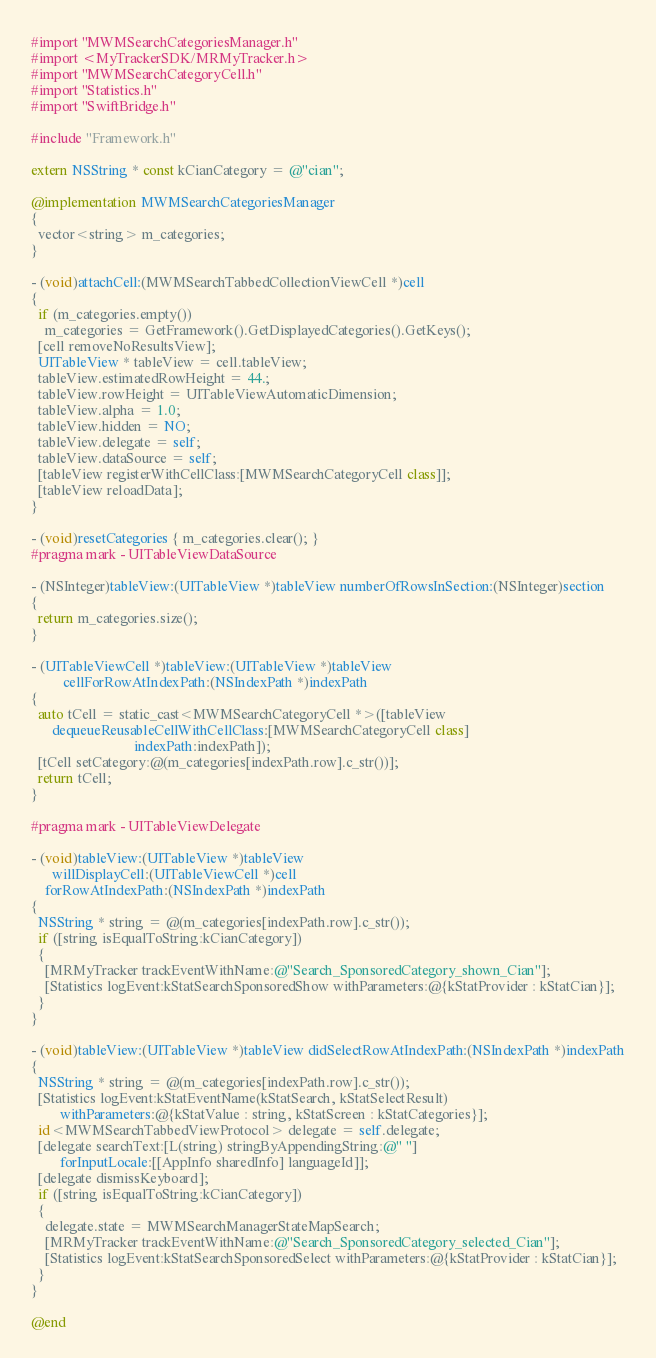<code> <loc_0><loc_0><loc_500><loc_500><_ObjectiveC_>#import "MWMSearchCategoriesManager.h"
#import <MyTrackerSDK/MRMyTracker.h>
#import "MWMSearchCategoryCell.h"
#import "Statistics.h"
#import "SwiftBridge.h"

#include "Framework.h"

extern NSString * const kCianCategory = @"cian";

@implementation MWMSearchCategoriesManager
{
  vector<string> m_categories;
}

- (void)attachCell:(MWMSearchTabbedCollectionViewCell *)cell
{
  if (m_categories.empty())
    m_categories = GetFramework().GetDisplayedCategories().GetKeys();
  [cell removeNoResultsView];
  UITableView * tableView = cell.tableView;
  tableView.estimatedRowHeight = 44.;
  tableView.rowHeight = UITableViewAutomaticDimension;
  tableView.alpha = 1.0;
  tableView.hidden = NO;
  tableView.delegate = self;
  tableView.dataSource = self;
  [tableView registerWithCellClass:[MWMSearchCategoryCell class]];
  [tableView reloadData];
}

- (void)resetCategories { m_categories.clear(); }
#pragma mark - UITableViewDataSource

- (NSInteger)tableView:(UITableView *)tableView numberOfRowsInSection:(NSInteger)section
{
  return m_categories.size();
}

- (UITableViewCell *)tableView:(UITableView *)tableView
         cellForRowAtIndexPath:(NSIndexPath *)indexPath
{
  auto tCell = static_cast<MWMSearchCategoryCell *>([tableView
      dequeueReusableCellWithCellClass:[MWMSearchCategoryCell class]
                             indexPath:indexPath]);
  [tCell setCategory:@(m_categories[indexPath.row].c_str())];
  return tCell;
}

#pragma mark - UITableViewDelegate

- (void)tableView:(UITableView *)tableView
      willDisplayCell:(UITableViewCell *)cell
    forRowAtIndexPath:(NSIndexPath *)indexPath
{
  NSString * string = @(m_categories[indexPath.row].c_str());
  if ([string isEqualToString:kCianCategory])
  {
    [MRMyTracker trackEventWithName:@"Search_SponsoredCategory_shown_Cian"];
    [Statistics logEvent:kStatSearchSponsoredShow withParameters:@{kStatProvider : kStatCian}];
  }
}

- (void)tableView:(UITableView *)tableView didSelectRowAtIndexPath:(NSIndexPath *)indexPath
{
  NSString * string = @(m_categories[indexPath.row].c_str());
  [Statistics logEvent:kStatEventName(kStatSearch, kStatSelectResult)
        withParameters:@{kStatValue : string, kStatScreen : kStatCategories}];
  id<MWMSearchTabbedViewProtocol> delegate = self.delegate;
  [delegate searchText:[L(string) stringByAppendingString:@" "]
        forInputLocale:[[AppInfo sharedInfo] languageId]];
  [delegate dismissKeyboard];
  if ([string isEqualToString:kCianCategory])
  {
    delegate.state = MWMSearchManagerStateMapSearch;
    [MRMyTracker trackEventWithName:@"Search_SponsoredCategory_selected_Cian"];
    [Statistics logEvent:kStatSearchSponsoredSelect withParameters:@{kStatProvider : kStatCian}];
  }
}

@end
</code> 